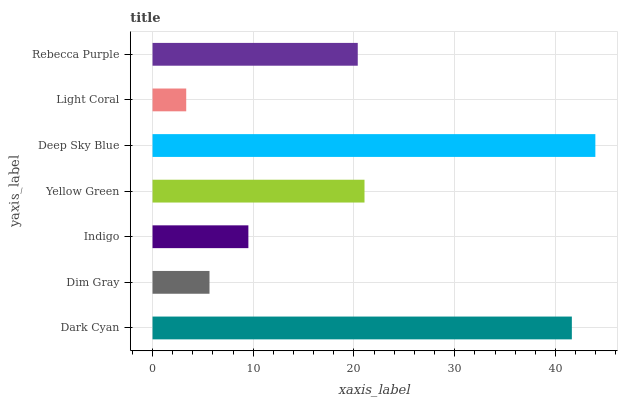Is Light Coral the minimum?
Answer yes or no. Yes. Is Deep Sky Blue the maximum?
Answer yes or no. Yes. Is Dim Gray the minimum?
Answer yes or no. No. Is Dim Gray the maximum?
Answer yes or no. No. Is Dark Cyan greater than Dim Gray?
Answer yes or no. Yes. Is Dim Gray less than Dark Cyan?
Answer yes or no. Yes. Is Dim Gray greater than Dark Cyan?
Answer yes or no. No. Is Dark Cyan less than Dim Gray?
Answer yes or no. No. Is Rebecca Purple the high median?
Answer yes or no. Yes. Is Rebecca Purple the low median?
Answer yes or no. Yes. Is Light Coral the high median?
Answer yes or no. No. Is Yellow Green the low median?
Answer yes or no. No. 